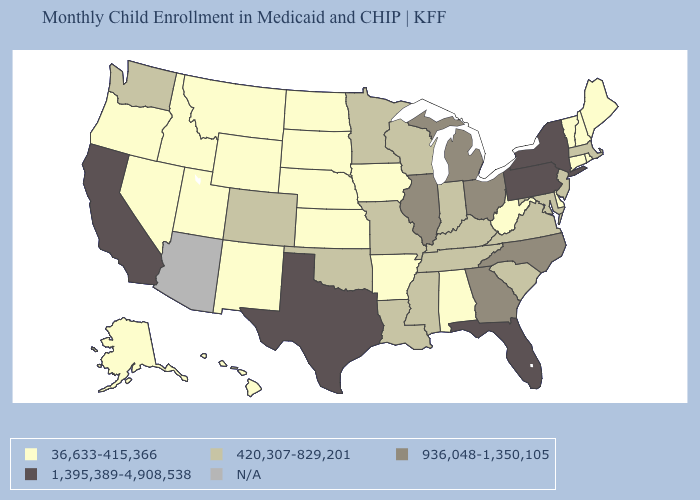What is the lowest value in the USA?
Answer briefly. 36,633-415,366. Among the states that border Indiana , does Michigan have the highest value?
Give a very brief answer. Yes. What is the value of Virginia?
Concise answer only. 420,307-829,201. Name the states that have a value in the range 420,307-829,201?
Be succinct. Colorado, Indiana, Kentucky, Louisiana, Maryland, Massachusetts, Minnesota, Mississippi, Missouri, New Jersey, Oklahoma, South Carolina, Tennessee, Virginia, Washington, Wisconsin. Among the states that border New Mexico , does Utah have the highest value?
Short answer required. No. Name the states that have a value in the range 936,048-1,350,105?
Quick response, please. Georgia, Illinois, Michigan, North Carolina, Ohio. How many symbols are there in the legend?
Answer briefly. 5. Among the states that border Maine , which have the highest value?
Answer briefly. New Hampshire. What is the highest value in the MidWest ?
Keep it brief. 936,048-1,350,105. What is the value of North Carolina?
Concise answer only. 936,048-1,350,105. Name the states that have a value in the range 36,633-415,366?
Give a very brief answer. Alabama, Alaska, Arkansas, Connecticut, Delaware, Hawaii, Idaho, Iowa, Kansas, Maine, Montana, Nebraska, Nevada, New Hampshire, New Mexico, North Dakota, Oregon, Rhode Island, South Dakota, Utah, Vermont, West Virginia, Wyoming. What is the value of Kentucky?
Give a very brief answer. 420,307-829,201. Name the states that have a value in the range 1,395,389-4,908,538?
Be succinct. California, Florida, New York, Pennsylvania, Texas. Does the first symbol in the legend represent the smallest category?
Short answer required. Yes. What is the value of Iowa?
Keep it brief. 36,633-415,366. 